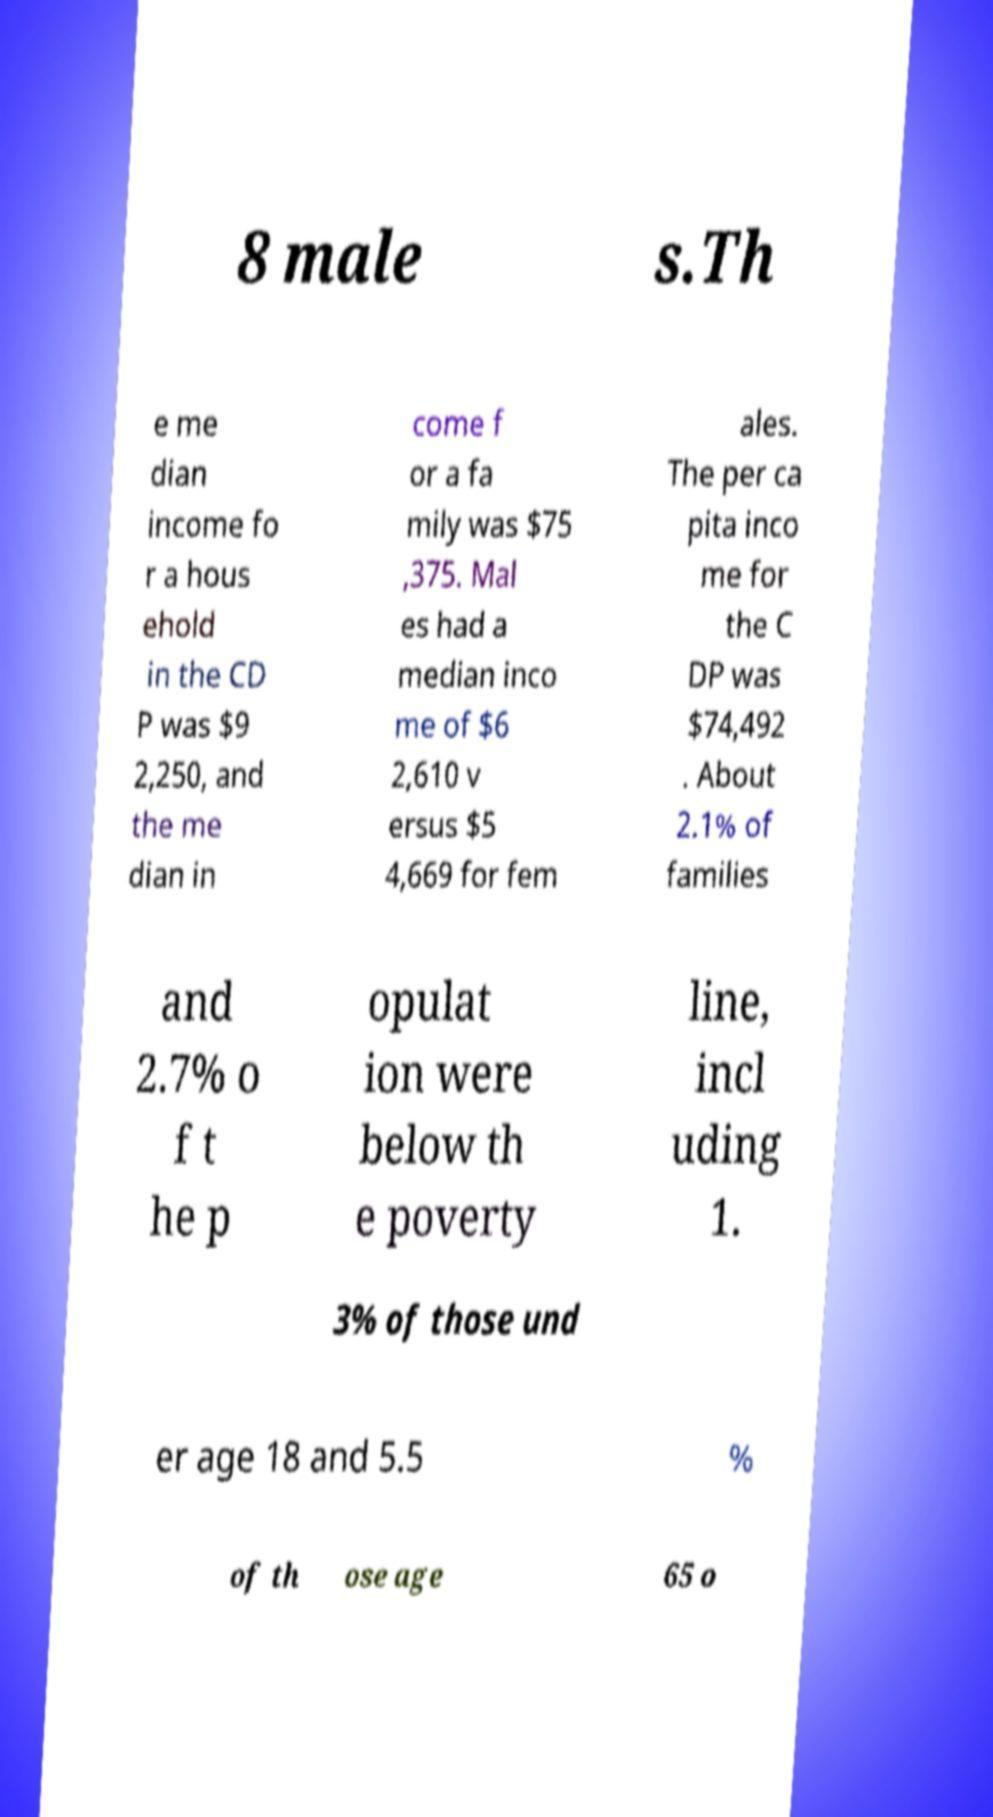Can you accurately transcribe the text from the provided image for me? 8 male s.Th e me dian income fo r a hous ehold in the CD P was $9 2,250, and the me dian in come f or a fa mily was $75 ,375. Mal es had a median inco me of $6 2,610 v ersus $5 4,669 for fem ales. The per ca pita inco me for the C DP was $74,492 . About 2.1% of families and 2.7% o f t he p opulat ion were below th e poverty line, incl uding 1. 3% of those und er age 18 and 5.5 % of th ose age 65 o 